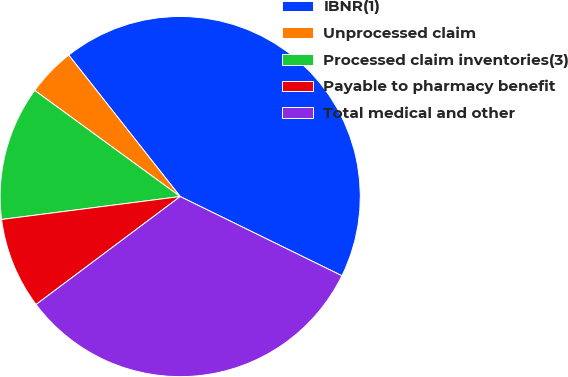Convert chart to OTSL. <chart><loc_0><loc_0><loc_500><loc_500><pie_chart><fcel>IBNR(1)<fcel>Unprocessed claim<fcel>Processed claim inventories(3)<fcel>Payable to pharmacy benefit<fcel>Total medical and other<nl><fcel>42.87%<fcel>4.35%<fcel>12.06%<fcel>8.2%<fcel>32.52%<nl></chart> 